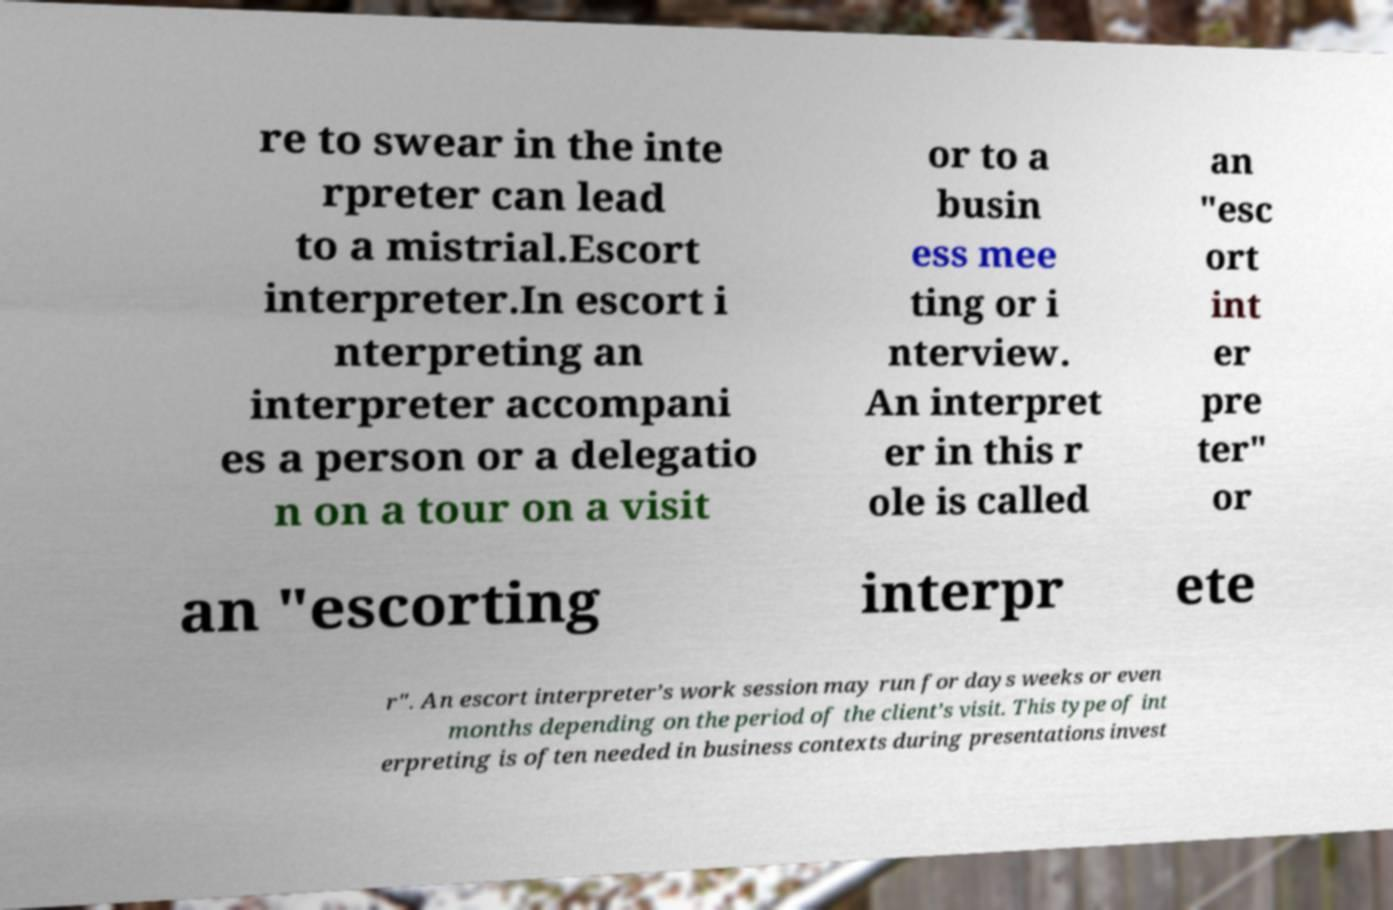Could you assist in decoding the text presented in this image and type it out clearly? re to swear in the inte rpreter can lead to a mistrial.Escort interpreter.In escort i nterpreting an interpreter accompani es a person or a delegatio n on a tour on a visit or to a busin ess mee ting or i nterview. An interpret er in this r ole is called an "esc ort int er pre ter" or an "escorting interpr ete r". An escort interpreter’s work session may run for days weeks or even months depending on the period of the client’s visit. This type of int erpreting is often needed in business contexts during presentations invest 